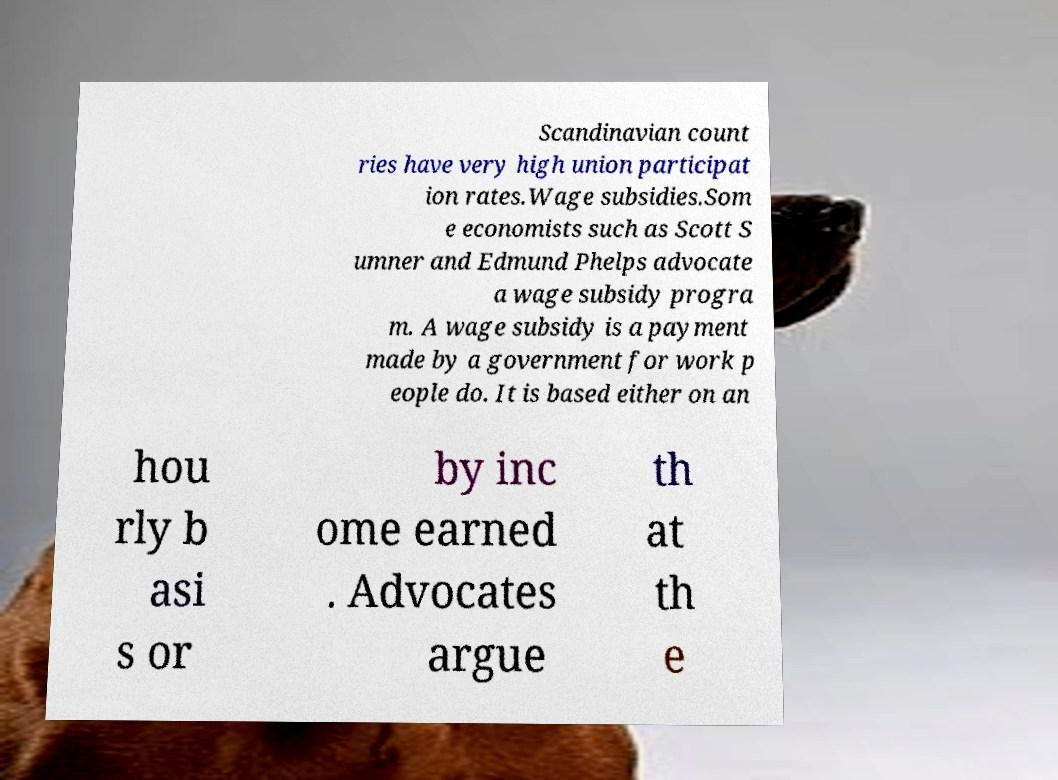Please read and relay the text visible in this image. What does it say? Scandinavian count ries have very high union participat ion rates.Wage subsidies.Som e economists such as Scott S umner and Edmund Phelps advocate a wage subsidy progra m. A wage subsidy is a payment made by a government for work p eople do. It is based either on an hou rly b asi s or by inc ome earned . Advocates argue th at th e 